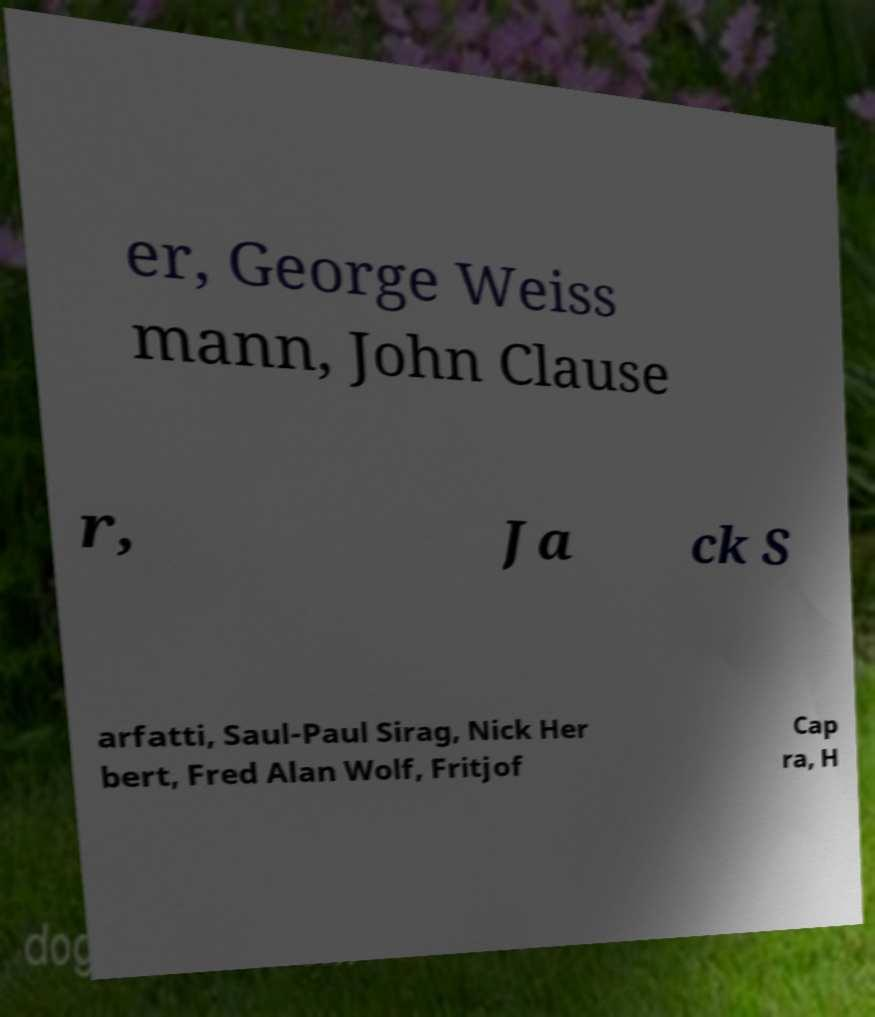Could you assist in decoding the text presented in this image and type it out clearly? er, George Weiss mann, John Clause r, Ja ck S arfatti, Saul-Paul Sirag, Nick Her bert, Fred Alan Wolf, Fritjof Cap ra, H 